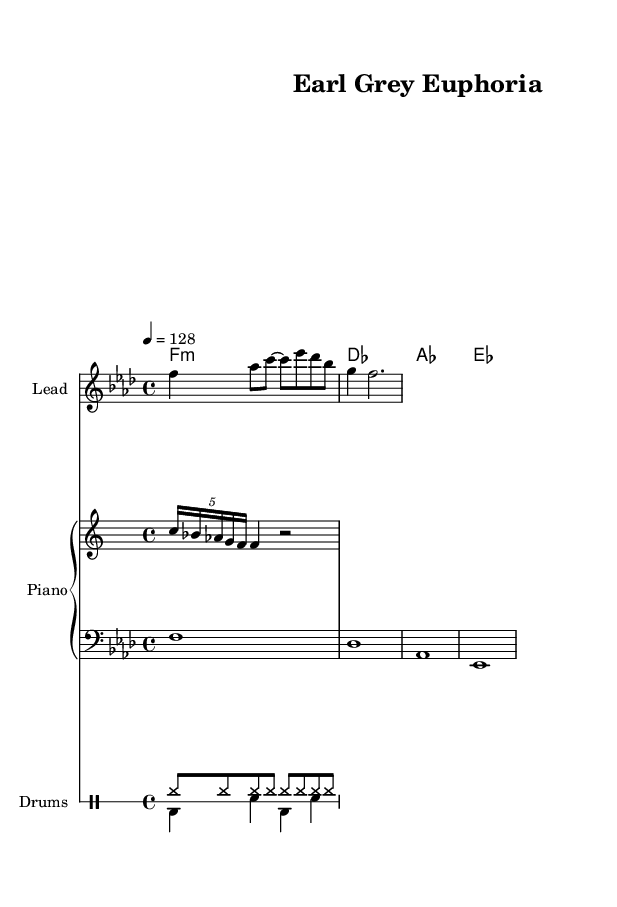What is the key signature of this music? The key is specified in the global section with `\key f \minor`, indicating the piece is in F minor, which has four flats (B, E, A, D).
Answer: F minor What is the time signature of the piece? The time signature is given in the global section as `\time 4/4`, meaning there are four beats in each measure, and the quarter note gets one beat.
Answer: 4/4 What is the tempo marking of the composition? The tempo is specified as `\tempo 4 = 128`, indicating that there are 128 beats per minute, which sets a brisk pace for the piece.
Answer: 128 How many measures are in the melody line? Counting the measure bars in the melody part, there are three measures present in the provided section of the music.
Answer: 3 What type of drum pattern is used in the upper voice? The upper drum pattern is indicated by `hh8 hh hh hh hh hh hh hh`, which represents a repetitive hi-hat rhythm commonly found in House music.
Answer: Hi-hat pattern Which chord is played in the second measure of the harmony? In the chord mode section, the second measure is indicated with `des`, which refers to the D-flat major chord played in that measure.
Answer: D-flat What is the overall theme that could be inferred from the title "Earl Grey Euphoria"? The title suggests a connection to the ambiance of Victorian tea rooms, likely evoking a warm, tranquil, and uplifting atmosphere.
Answer: Tea ambiance 